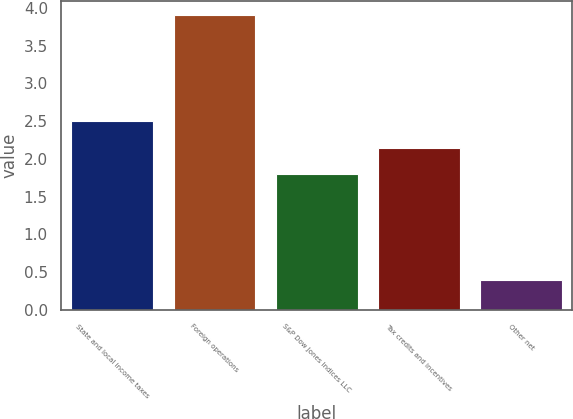<chart> <loc_0><loc_0><loc_500><loc_500><bar_chart><fcel>State and local income taxes<fcel>Foreign operations<fcel>S&P Dow Jones Indices LLC<fcel>Tax credits and incentives<fcel>Other net<nl><fcel>2.5<fcel>3.9<fcel>1.8<fcel>2.15<fcel>0.4<nl></chart> 